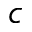Convert formula to latex. <formula><loc_0><loc_0><loc_500><loc_500>_ { c }</formula> 